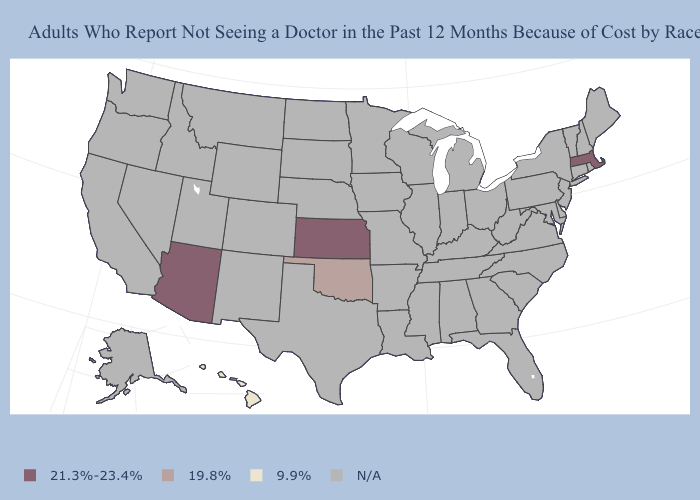What is the highest value in the Northeast ?
Short answer required. 21.3%-23.4%. Name the states that have a value in the range 19.8%?
Quick response, please. Oklahoma. Which states have the highest value in the USA?
Short answer required. Arizona, Kansas, Massachusetts. Name the states that have a value in the range 9.9%?
Write a very short answer. Hawaii. Which states hav the highest value in the MidWest?
Keep it brief. Kansas. Which states have the lowest value in the USA?
Concise answer only. Hawaii. Which states hav the highest value in the Northeast?
Keep it brief. Massachusetts. Name the states that have a value in the range 19.8%?
Quick response, please. Oklahoma. Name the states that have a value in the range 21.3%-23.4%?
Answer briefly. Arizona, Kansas, Massachusetts. What is the lowest value in the USA?
Give a very brief answer. 9.9%. What is the value of Indiana?
Short answer required. N/A. Which states have the lowest value in the USA?
Give a very brief answer. Hawaii. What is the lowest value in the West?
Answer briefly. 9.9%. Which states have the lowest value in the USA?
Quick response, please. Hawaii. How many symbols are there in the legend?
Quick response, please. 4. 